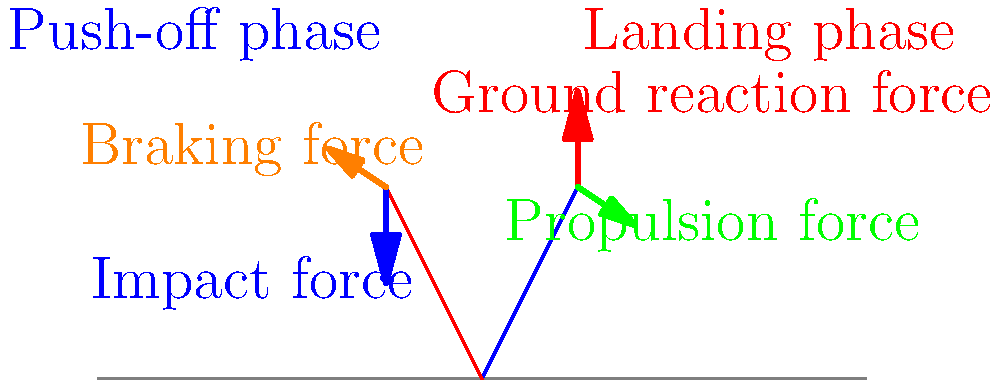As a runner who has persevered through economic challenges, you understand the importance of efficiency and balance. In the diagram, two phases of a runner's stride are shown: the push-off phase (blue) and the landing phase (red). Which force vector plays the most crucial role in propelling the runner forward during the push-off phase, and how does this relate to overcoming obstacles in life? Let's analyze the forces acting on the runner's leg during different phases of the stride:

1. Push-off phase (blue leg):
   - This phase is crucial for forward movement.
   - The green arrow represents the propulsion force.
   - This force is generated by the runner's muscles and is directed backward and downward.
   - It pushes against the ground, creating a forward reaction force on the runner.

2. Landing phase (red leg):
   - This phase absorbs the impact and prepares for the next push-off.
   - The red arrow shows the ground reaction force.
   - The blue arrow indicates the impact force.
   - The orange arrow represents the braking force.

3. Propulsion force (green arrow):
   - This is the most important force for moving forward.
   - It's created by the extension of the ankle, knee, and hip joints.
   - The magnitude and direction of this force determine the runner's speed and efficiency.

4. Relating to overcoming obstacles:
   - Just as the propulsion force helps a runner move forward against resistance, perseverance helps one overcome economic challenges.
   - The efficiency of the push-off phase can be likened to making the most of limited resources during tough times.
   - The balance between push-off and landing phases represents the need for resilience and adaptability in facing life's ups and downs.

Therefore, the propulsion force (green arrow) plays the most crucial role in propelling the runner forward during the push-off phase. This force symbolizes the determination and effort required to overcome obstacles and move forward in life, much like navigating through economic hardships.
Answer: Propulsion force (green arrow) 